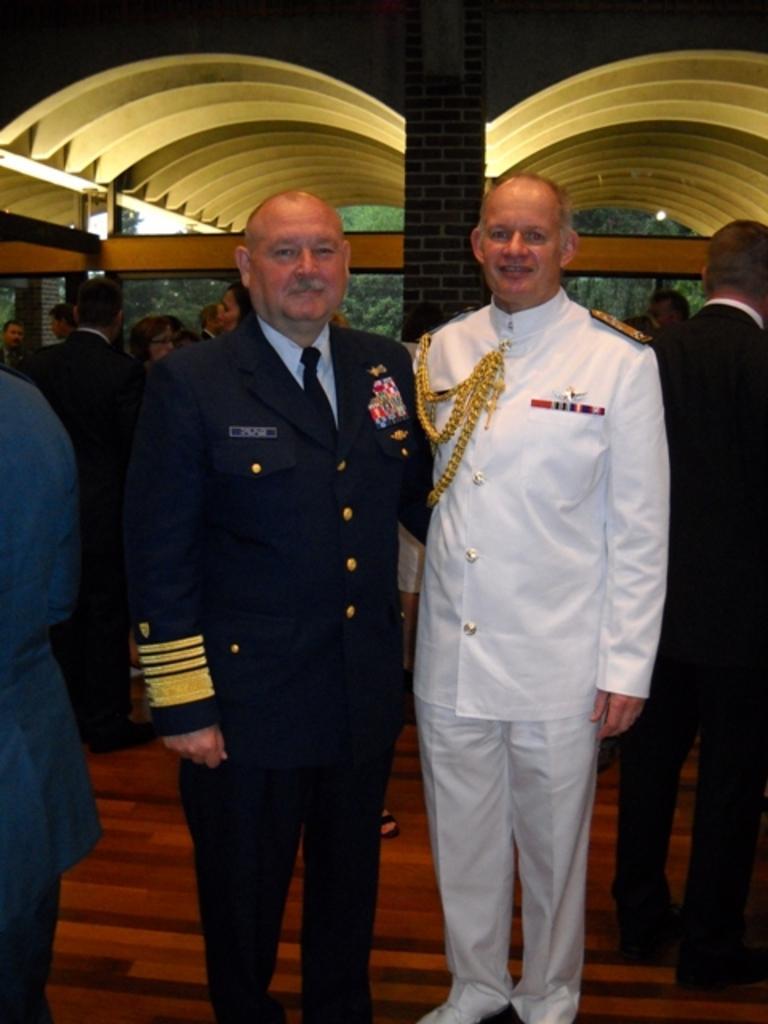Can you describe this image briefly? This picture describes about group of people, they are all standing, in the middle of the image we can see two men, they both are smiling, in the background we can see few lights and trees. 